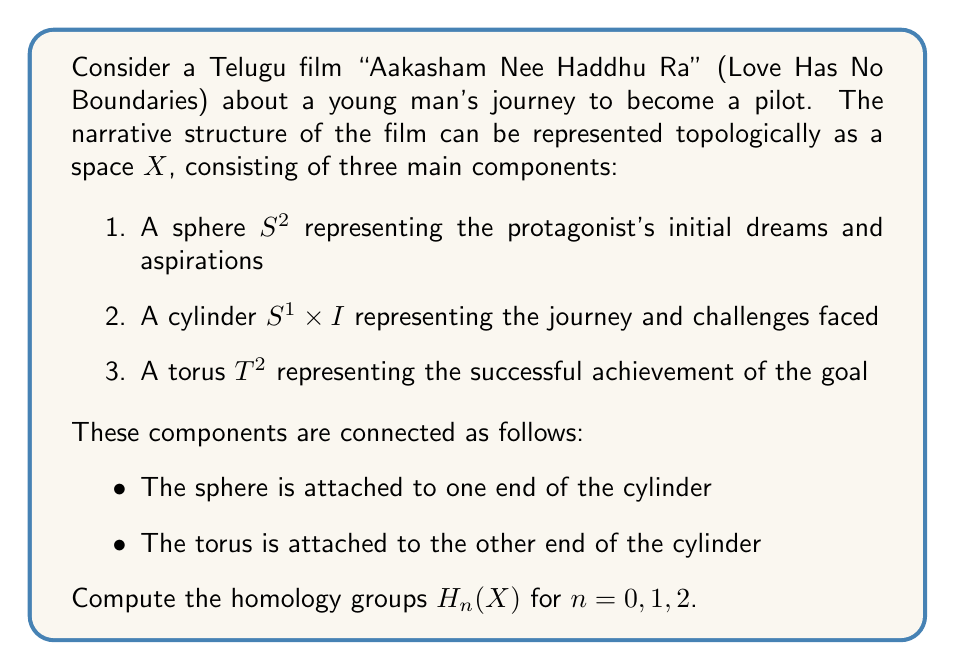Solve this math problem. To compute the homology groups of the space X, we'll use the Mayer-Vietoris sequence and the known homology groups of the individual components.

1. First, let's define our spaces:
   A = Sphere $S^2$ union Cylinder $S^1 \times I$
   B = Cylinder $S^1 \times I$ union Torus $T^2$
   A ∩ B = Cylinder $S^1 \times I$

2. The Mayer-Vietoris sequence gives us:
   $$... \to H_n(A \cap B) \to H_n(A) \oplus H_n(B) \to H_n(X) \to H_{n-1}(A \cap B) \to ...$$

3. Let's compute the homology groups for each component:

   For $S^2$: $H_0(S^2) \cong \mathbb{Z}$, $H_2(S^2) \cong \mathbb{Z}$, others are 0
   For $S^1 \times I$: $H_0(S^1 \times I) \cong \mathbb{Z}$, $H_1(S^1 \times I) \cong \mathbb{Z}$, others are 0
   For $T^2$: $H_0(T^2) \cong \mathbb{Z}$, $H_1(T^2) \cong \mathbb{Z} \oplus \mathbb{Z}$, $H_2(T^2) \cong \mathbb{Z}$, others are 0

4. Now, let's compute $H_n(X)$ for $n = 0, 1, 2$:

   For $n = 0$:
   $H_0(A \cap B) \to H_0(A) \oplus H_0(B) \to H_0(X) \to 0$
   $\mathbb{Z} \to \mathbb{Z} \oplus \mathbb{Z} \to H_0(X) \to 0$
   This gives us $H_0(X) \cong \mathbb{Z}$

   For $n = 1$:
   $H_1(A \cap B) \to H_1(A) \oplus H_1(B) \to H_1(X) \to H_0(A \cap B) \to H_0(A) \oplus H_0(B)$
   $\mathbb{Z} \to \mathbb{Z} \oplus (\mathbb{Z} \oplus \mathbb{Z}) \to H_1(X) \to \mathbb{Z} \to \mathbb{Z} \oplus \mathbb{Z}$
   This gives us $H_1(X) \cong \mathbb{Z} \oplus \mathbb{Z}$

   For $n = 2$:
   $H_2(A \cap B) \to H_2(A) \oplus H_2(B) \to H_2(X) \to H_1(A \cap B)$
   $0 \to \mathbb{Z} \oplus \mathbb{Z} \to H_2(X) \to \mathbb{Z}$
   This gives us $H_2(X) \cong \mathbb{Z} \oplus \mathbb{Z}$
Answer: The homology groups of X are:

$H_0(X) \cong \mathbb{Z}$
$H_1(X) \cong \mathbb{Z} \oplus \mathbb{Z}$
$H_2(X) \cong \mathbb{Z} \oplus \mathbb{Z}$ 